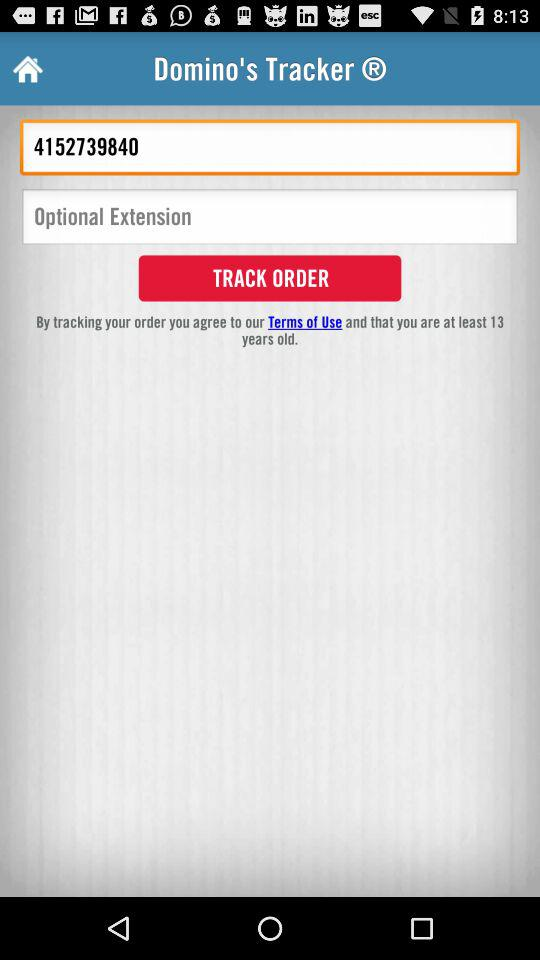How many text inputs are on the screen?
Answer the question using a single word or phrase. 2 